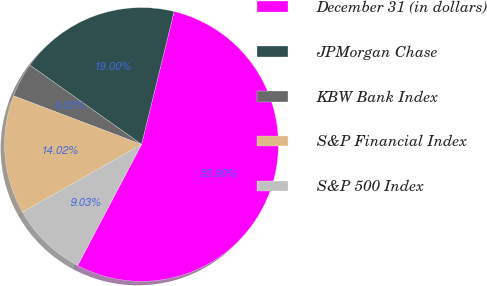Convert chart to OTSL. <chart><loc_0><loc_0><loc_500><loc_500><pie_chart><fcel>December 31 (in dollars)<fcel>JPMorgan Chase<fcel>KBW Bank Index<fcel>S&P Financial Index<fcel>S&P 500 Index<nl><fcel>53.9%<fcel>19.0%<fcel>4.05%<fcel>14.02%<fcel>9.03%<nl></chart> 